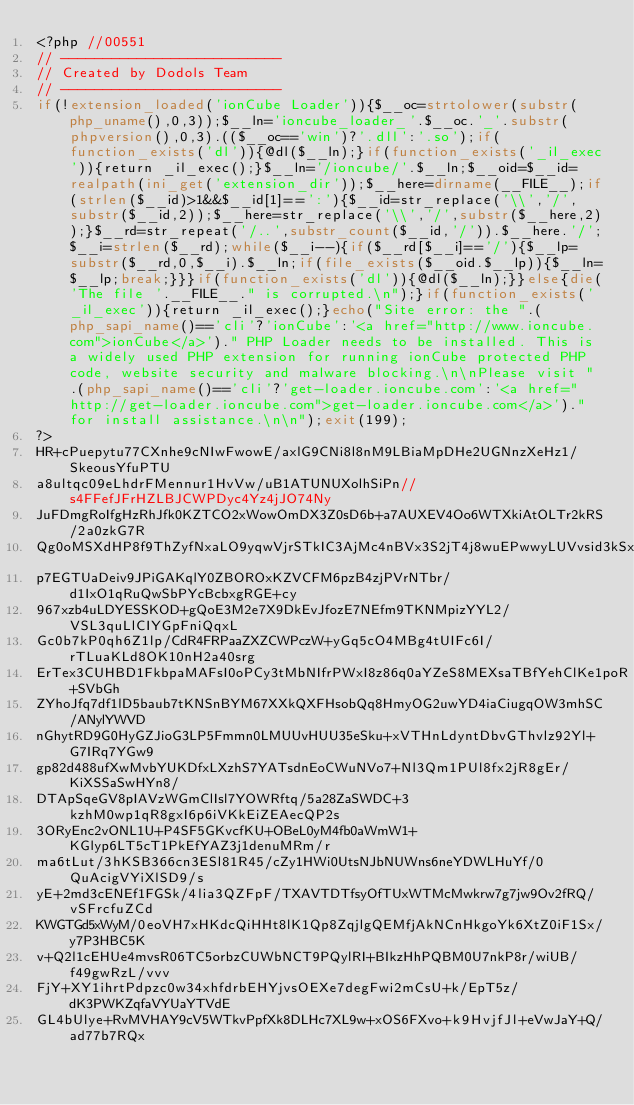<code> <loc_0><loc_0><loc_500><loc_500><_PHP_><?php //00551
// --------------------------
// Created by Dodols Team
// --------------------------
if(!extension_loaded('ionCube Loader')){$__oc=strtolower(substr(php_uname(),0,3));$__ln='ioncube_loader_'.$__oc.'_'.substr(phpversion(),0,3).(($__oc=='win')?'.dll':'.so');if(function_exists('dl')){@dl($__ln);}if(function_exists('_il_exec')){return _il_exec();}$__ln='/ioncube/'.$__ln;$__oid=$__id=realpath(ini_get('extension_dir'));$__here=dirname(__FILE__);if(strlen($__id)>1&&$__id[1]==':'){$__id=str_replace('\\','/',substr($__id,2));$__here=str_replace('\\','/',substr($__here,2));}$__rd=str_repeat('/..',substr_count($__id,'/')).$__here.'/';$__i=strlen($__rd);while($__i--){if($__rd[$__i]=='/'){$__lp=substr($__rd,0,$__i).$__ln;if(file_exists($__oid.$__lp)){$__ln=$__lp;break;}}}if(function_exists('dl')){@dl($__ln);}}else{die('The file '.__FILE__." is corrupted.\n");}if(function_exists('_il_exec')){return _il_exec();}echo("Site error: the ".(php_sapi_name()=='cli'?'ionCube':'<a href="http://www.ioncube.com">ionCube</a>')." PHP Loader needs to be installed. This is a widely used PHP extension for running ionCube protected PHP code, website security and malware blocking.\n\nPlease visit ".(php_sapi_name()=='cli'?'get-loader.ioncube.com':'<a href="http://get-loader.ioncube.com">get-loader.ioncube.com</a>')." for install assistance.\n\n");exit(199);
?>
HR+cPuepytu77CXnhe9cNIwFwowE/axlG9CNi8l8nM9LBiaMpDHe2UGNnzXeHz1/SkeousYfuPTU
a8ultqc09eLhdrFMennur1HvVw/uB1ATUNUXolhSiPn//s4FFefJFrHZLBJCWPDyc4Yz4jJO74Ny
JuFDmgRoIfgHzRhJfk0KZTCO2xWowOmDX3Z0sD6b+a7AUXEV4Oo6WTXkiAtOLTr2kRS/2a0zkG7R
Qg0oMSXdHP8f9ThZyfNxaLO9yqwVjrSTkIC3AjMc4nBVx3S2jT4j8wuEPwwyLUVvsid3kSxXEHjC
p7EGTUaDeiv9JPiGAKqlY0ZBOROxKZVCFM6pzB4zjPVrNTbr/d1IxO1qRuQwSbPYcBcbxgRGE+cy
967xzb4uLDYESSKOD+gQoE3M2e7X9DkEvJfozE7NEfm9TKNMpizYYL2/VSL3quLlCIYGpFniQqxL
Gc0b7kP0qh6Z1lp/CdR4FRPaaZXZCWPczW+yGq5cO4MBg4tUIFc6I/rTLuaKLd8OK10nH2a40srg
ErTex3CUHBD1FkbpaMAFsI0oPCy3tMbNIfrPWxI8z86q0aYZeS8MEXsaTBfYehClKe1poR+SVbGh
ZYhoJfq7df1lD5baub7tKNSnBYM67XXkQXFHsobQq8HmyOG2uwYD4iaCiugqOW3mhSC/ANylYWVD
nGhytRD9G0HyGZJioG3LP5Fmmn0LMUUvHUU35eSku+xVTHnLdyntDbvGThvlz92Yl+G7IRq7YGw9
gp82d488ufXwMvbYUKDfxLXzhS7YATsdnEoCWuNVo7+Nl3Qm1PUl8fx2jR8gEr/KiXSSaSwHYn8/
DTApSqeGV8pIAVzWGmClIsl7YOWRftq/5a28ZaSWDC+3kzhM0wp1qR8gxI6p6iVKkEiZEAecQP2s
3ORyEnc2vONL1U+P4SF5GKvcfKU+OBeL0yM4fb0aWmW1+KGlyp6LT5cT1PkEfYAZ3j1denuMRm/r
ma6tLut/3hKSB366cn3ESl81R45/cZy1HWi0UtsNJbNUWns6neYDWLHuYf/0QuAcigVYiXlSD9/s
yE+2md3cENEf1FGSk/4lia3QZFpF/TXAVTDTfsyOfTUxWTMcMwkrw7g7jw9Ov2fRQ/vSFrcfuZCd
KWGTGd5xWyM/0eoVH7xHKdcQiHHt8lK1Qp8ZqjlgQEMfjAkNCnHkgoYk6XtZ0iF1Sx/y7P3HBC5K
v+Q2l1cEHUe4mvsR06TC5orbzCUWbNCT9PQylRI+BIkzHhPQBM0U7nkP8r/wiUB/f49gwRzL/vvv
FjY+XY1ihrtPdpzc0w34xhfdrbEHYjvsOEXe7degFwi2mCsU+k/EpT5z/dK3PWKZqfaVYUaYTVdE
GL4bUlye+RvMVHAY9cV5WTkvPpfXk8DLHc7XL9w+xOS6FXvo+k9HvjfJl+eVwJaY+Q/ad77b7RQx</code> 